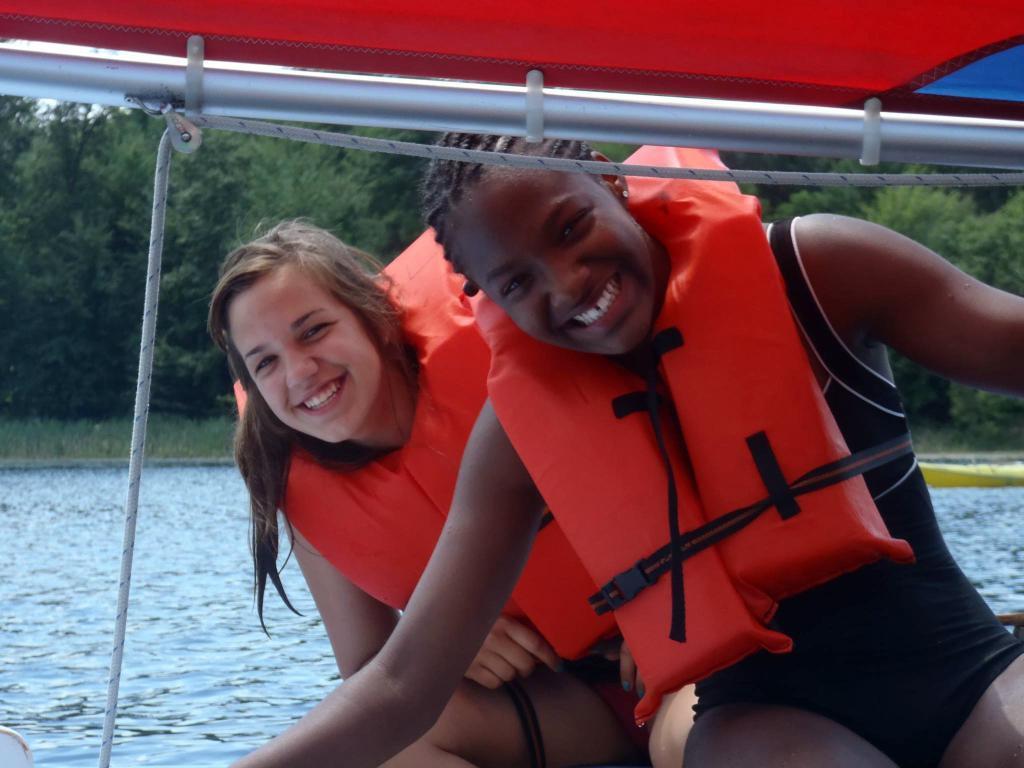How would you summarize this image in a sentence or two? This picture is clicked outside the city. In the center we can see the two persons wearing life jackets, smiling and seems to be sitting and we can see the metal rod, rope. In the background we can see a water body, green grass, trees and some other objects. 